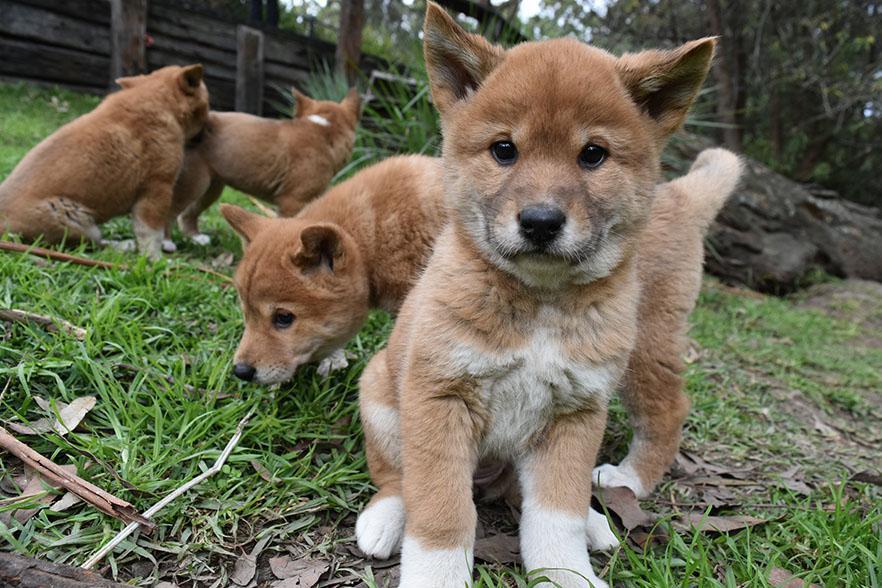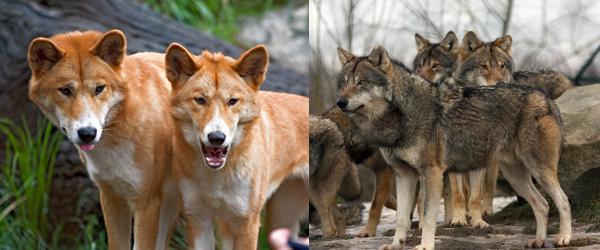The first image is the image on the left, the second image is the image on the right. Examine the images to the left and right. Is the description "There are no more than 3 animals in the pair of images." accurate? Answer yes or no. No. The first image is the image on the left, the second image is the image on the right. Analyze the images presented: Is the assertion "The right image contains at least two wolves." valid? Answer yes or no. Yes. 